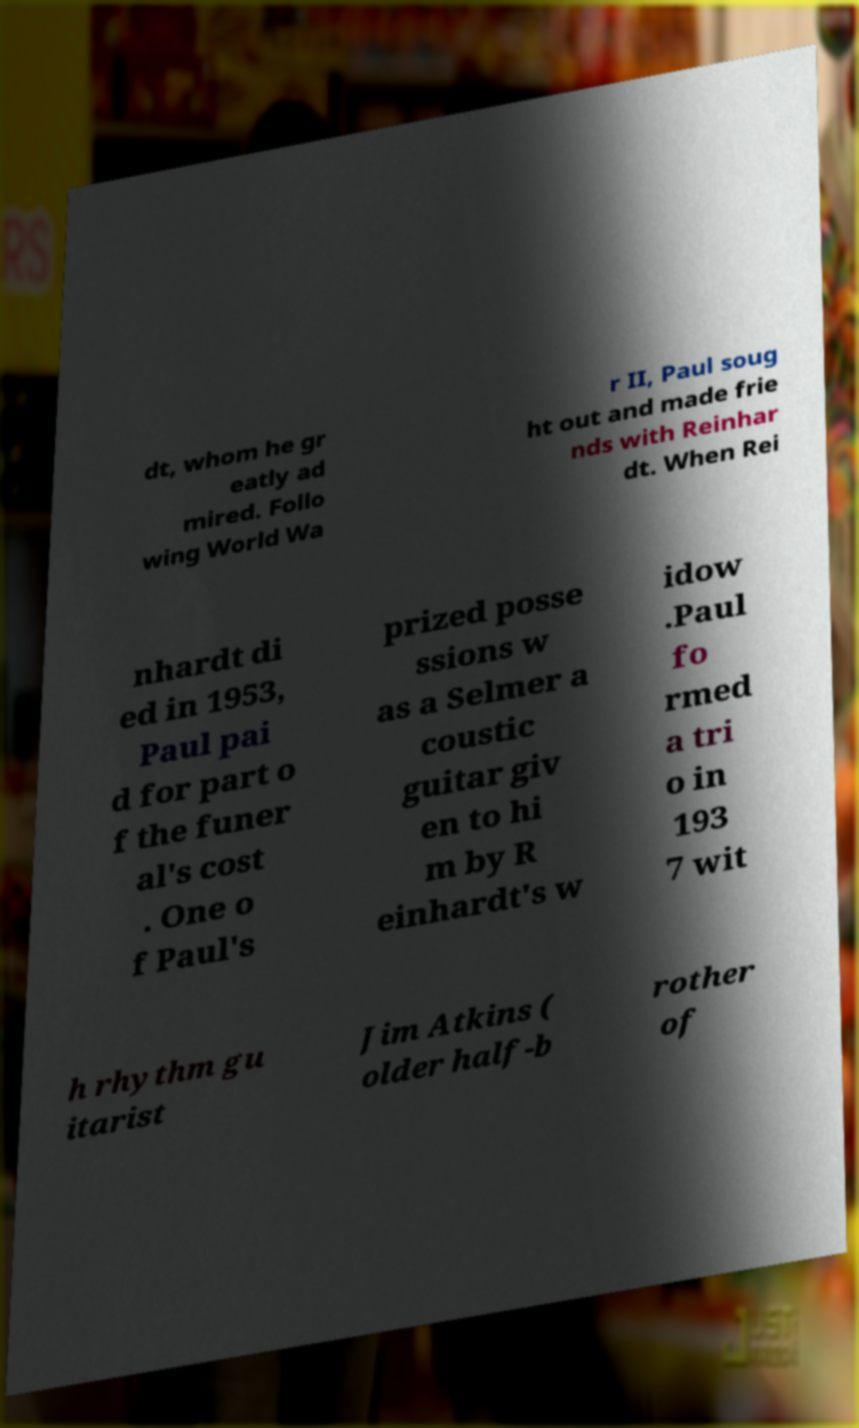Please identify and transcribe the text found in this image. dt, whom he gr eatly ad mired. Follo wing World Wa r II, Paul soug ht out and made frie nds with Reinhar dt. When Rei nhardt di ed in 1953, Paul pai d for part o f the funer al's cost . One o f Paul's prized posse ssions w as a Selmer a coustic guitar giv en to hi m by R einhardt's w idow .Paul fo rmed a tri o in 193 7 wit h rhythm gu itarist Jim Atkins ( older half-b rother of 